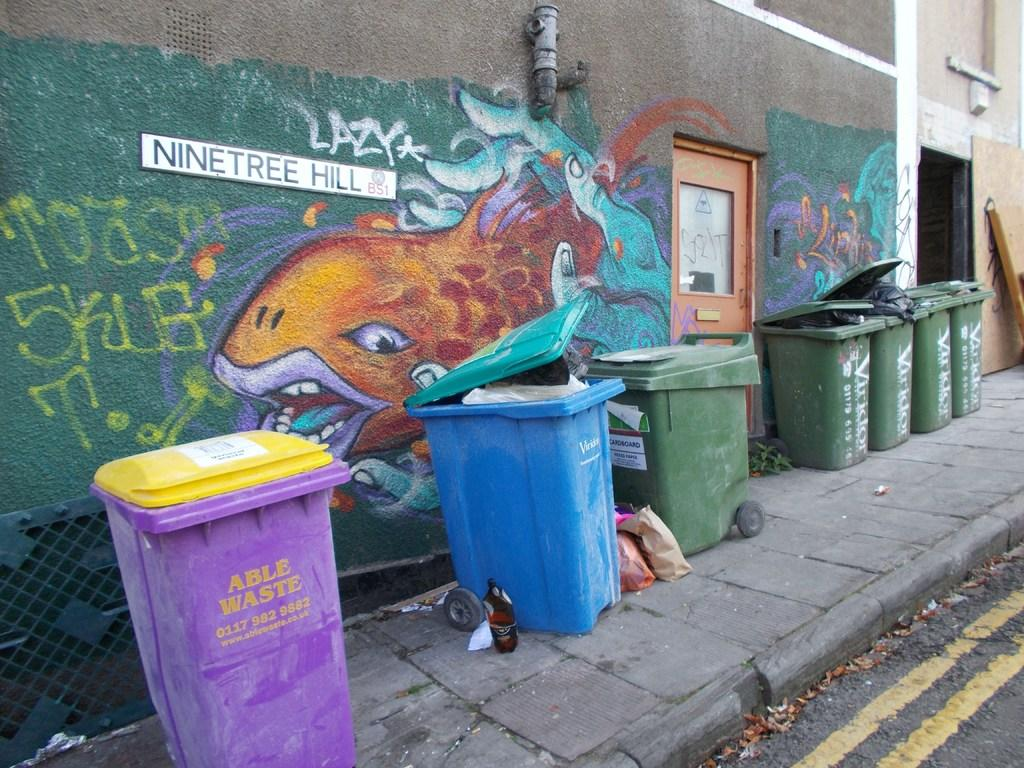<image>
Provide a brief description of the given image. A sign that says Nine Tree Hill next to a drawing of a fish. 